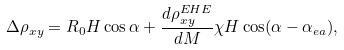<formula> <loc_0><loc_0><loc_500><loc_500>\Delta \rho _ { x y } = R _ { 0 } H \cos \alpha + \frac { d \rho _ { x y } ^ { E H E } } { d M } \chi H \cos ( \alpha - \alpha _ { e a } ) ,</formula> 